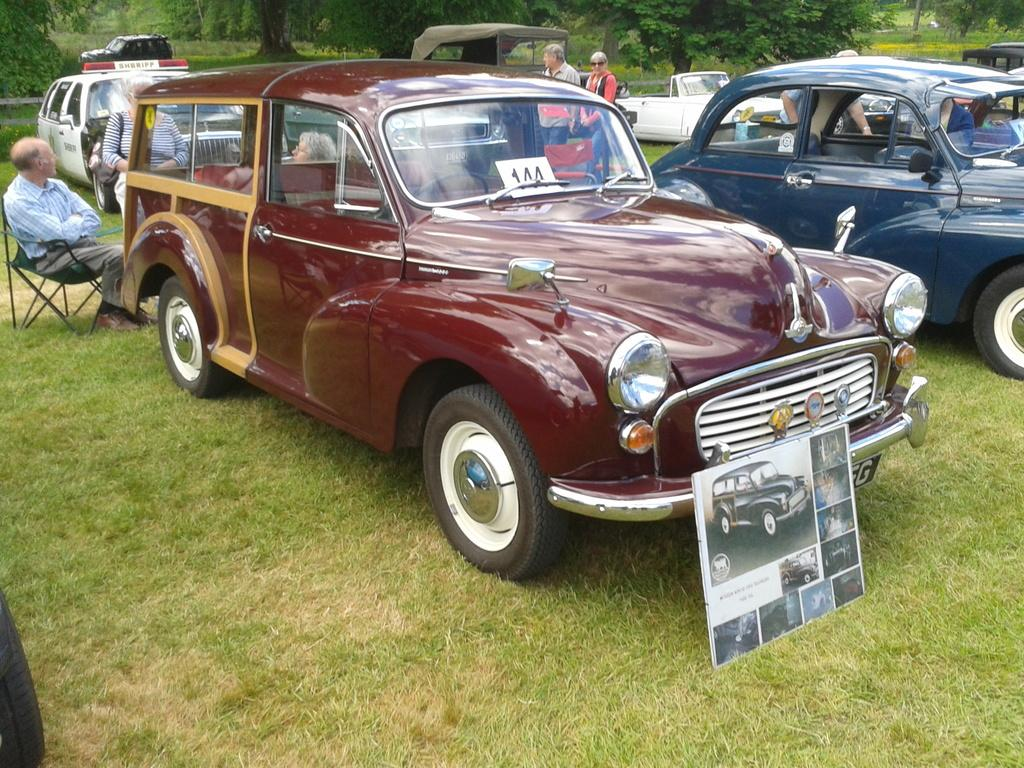What types of objects are present in the image? There are vehicles and a board in the image. Can you describe the people in the image? There are people on the ground in the image. Where is the person sitting in the image? There is a person sitting on a chair on the left side of the image. What can be seen in the background of the image? There are trees in the background of the image. How many bags are being used by the people in the image? There is no mention of bags in the image; the focus is on vehicles, people, a board, a person sitting on a chair, and trees in the background. 